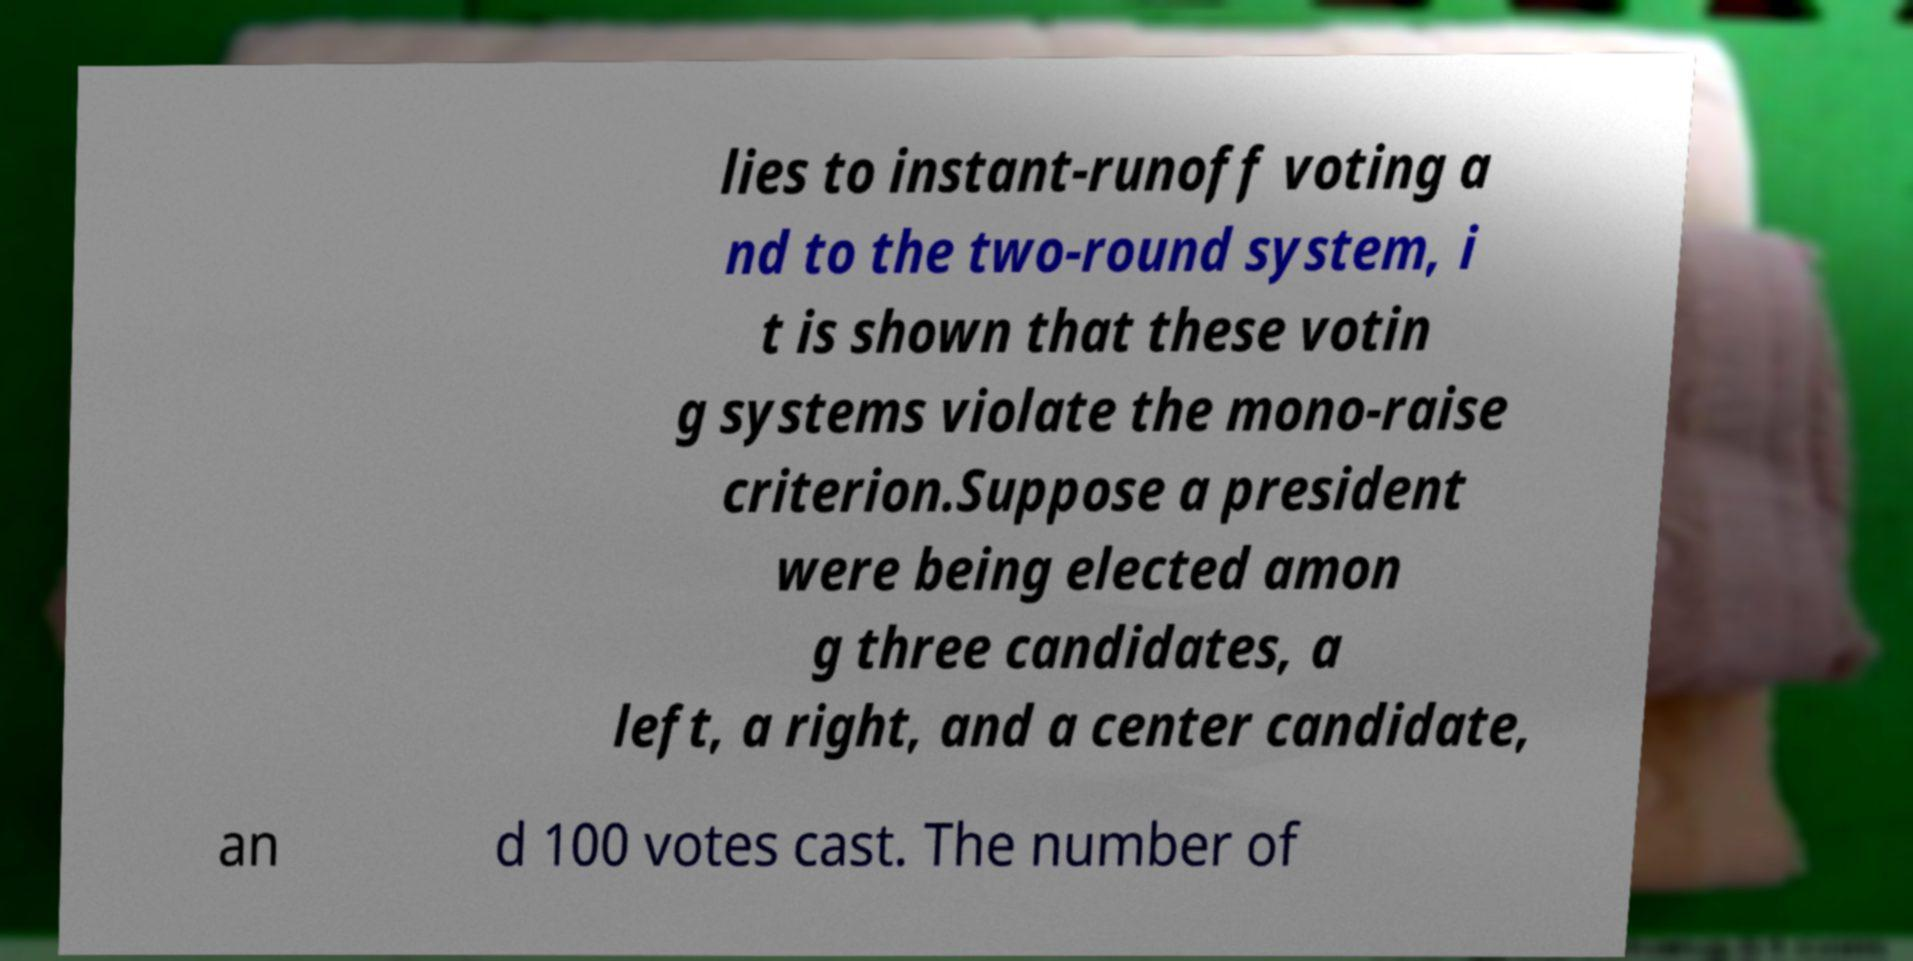I need the written content from this picture converted into text. Can you do that? lies to instant-runoff voting a nd to the two-round system, i t is shown that these votin g systems violate the mono-raise criterion.Suppose a president were being elected amon g three candidates, a left, a right, and a center candidate, an d 100 votes cast. The number of 